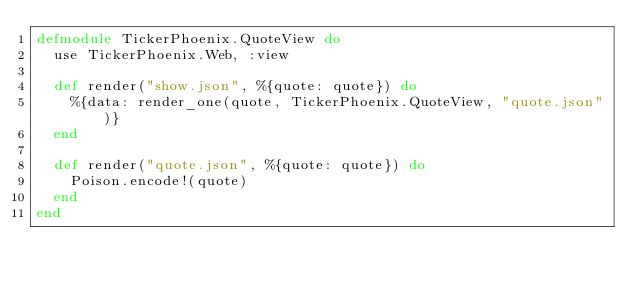<code> <loc_0><loc_0><loc_500><loc_500><_Elixir_>defmodule TickerPhoenix.QuoteView do
  use TickerPhoenix.Web, :view

  def render("show.json", %{quote: quote}) do
    %{data: render_one(quote, TickerPhoenix.QuoteView, "quote.json")}
  end

  def render("quote.json", %{quote: quote}) do
    Poison.encode!(quote)
  end
end
</code> 